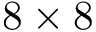<formula> <loc_0><loc_0><loc_500><loc_500>8 \times 8</formula> 